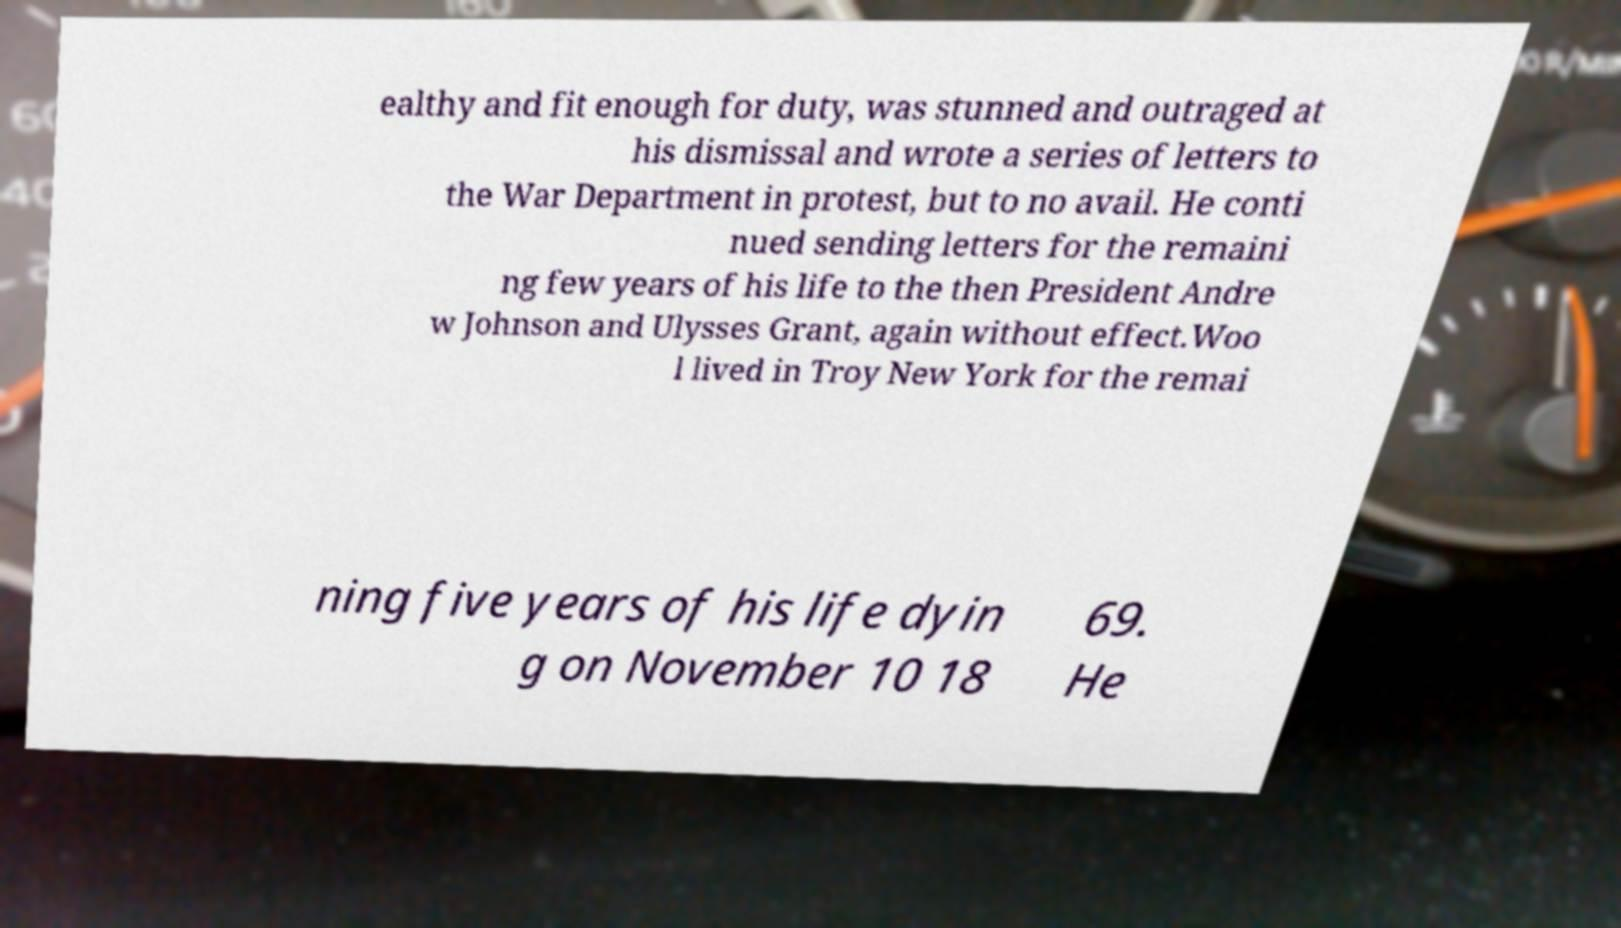For documentation purposes, I need the text within this image transcribed. Could you provide that? ealthy and fit enough for duty, was stunned and outraged at his dismissal and wrote a series of letters to the War Department in protest, but to no avail. He conti nued sending letters for the remaini ng few years of his life to the then President Andre w Johnson and Ulysses Grant, again without effect.Woo l lived in Troy New York for the remai ning five years of his life dyin g on November 10 18 69. He 